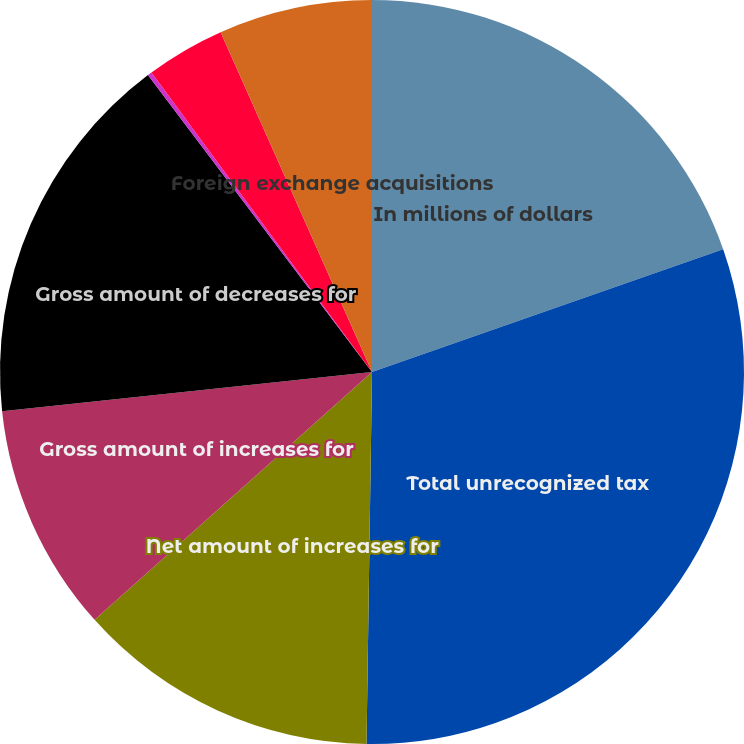Convert chart. <chart><loc_0><loc_0><loc_500><loc_500><pie_chart><fcel>In millions of dollars<fcel>Total unrecognized tax<fcel>Net amount of increases for<fcel>Gross amount of increases for<fcel>Gross amount of decreases for<fcel>Amounts of decreases relating<fcel>Reductions due to lapse of<fcel>Foreign exchange acquisitions<nl><fcel>19.65%<fcel>30.59%<fcel>13.16%<fcel>9.92%<fcel>16.4%<fcel>0.19%<fcel>3.43%<fcel>6.67%<nl></chart> 